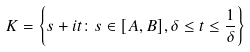<formula> <loc_0><loc_0><loc_500><loc_500>K = \left \{ s + i t \colon s \in [ A , B ] , \delta \leq t \leq \frac { 1 } { \delta } \right \}</formula> 